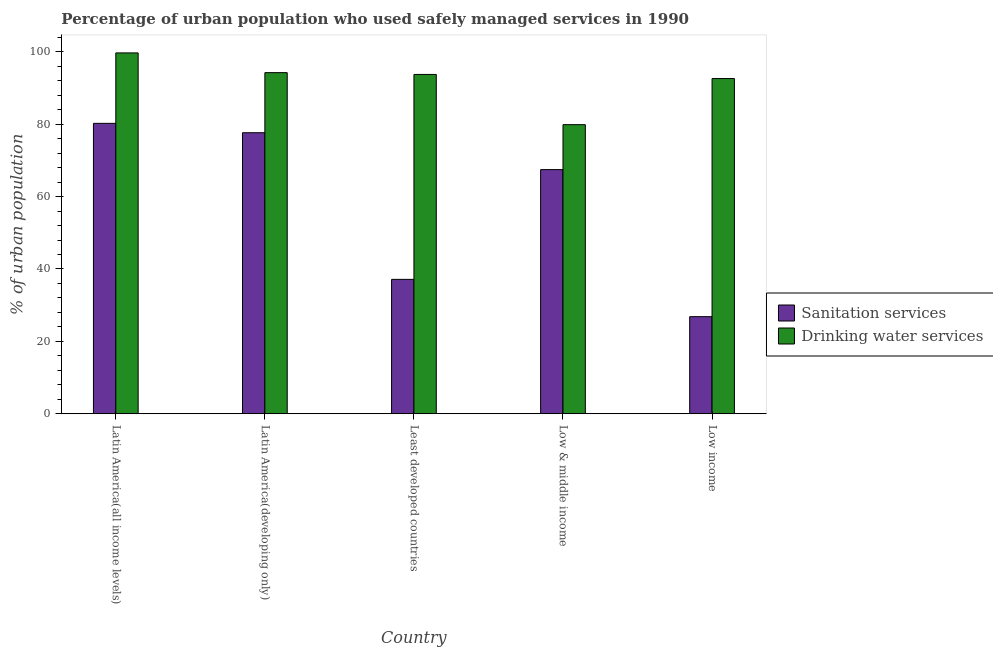How many groups of bars are there?
Give a very brief answer. 5. Are the number of bars per tick equal to the number of legend labels?
Give a very brief answer. Yes. How many bars are there on the 1st tick from the left?
Ensure brevity in your answer.  2. How many bars are there on the 3rd tick from the right?
Give a very brief answer. 2. What is the percentage of urban population who used sanitation services in Low income?
Provide a succinct answer. 26.82. Across all countries, what is the maximum percentage of urban population who used drinking water services?
Give a very brief answer. 99.69. Across all countries, what is the minimum percentage of urban population who used sanitation services?
Provide a succinct answer. 26.82. In which country was the percentage of urban population who used sanitation services maximum?
Give a very brief answer. Latin America(all income levels). In which country was the percentage of urban population who used sanitation services minimum?
Ensure brevity in your answer.  Low income. What is the total percentage of urban population who used drinking water services in the graph?
Make the answer very short. 460.16. What is the difference between the percentage of urban population who used drinking water services in Low & middle income and that in Low income?
Keep it short and to the point. -12.74. What is the difference between the percentage of urban population who used sanitation services in Latin America(all income levels) and the percentage of urban population who used drinking water services in Low & middle income?
Give a very brief answer. 0.36. What is the average percentage of urban population who used sanitation services per country?
Provide a short and direct response. 57.85. What is the difference between the percentage of urban population who used sanitation services and percentage of urban population who used drinking water services in Latin America(all income levels)?
Provide a succinct answer. -19.46. In how many countries, is the percentage of urban population who used drinking water services greater than 92 %?
Keep it short and to the point. 4. What is the ratio of the percentage of urban population who used drinking water services in Latin America(developing only) to that in Least developed countries?
Provide a succinct answer. 1.01. Is the percentage of urban population who used sanitation services in Latin America(all income levels) less than that in Least developed countries?
Offer a terse response. No. What is the difference between the highest and the second highest percentage of urban population who used sanitation services?
Provide a short and direct response. 2.59. What is the difference between the highest and the lowest percentage of urban population who used drinking water services?
Provide a succinct answer. 19.82. What does the 1st bar from the left in Low income represents?
Make the answer very short. Sanitation services. What does the 2nd bar from the right in Latin America(all income levels) represents?
Ensure brevity in your answer.  Sanitation services. Are all the bars in the graph horizontal?
Ensure brevity in your answer.  No. What is the difference between two consecutive major ticks on the Y-axis?
Your response must be concise. 20. Does the graph contain any zero values?
Provide a succinct answer. No. Where does the legend appear in the graph?
Your answer should be compact. Center right. How many legend labels are there?
Keep it short and to the point. 2. What is the title of the graph?
Offer a terse response. Percentage of urban population who used safely managed services in 1990. Does "From production" appear as one of the legend labels in the graph?
Ensure brevity in your answer.  No. What is the label or title of the X-axis?
Provide a short and direct response. Country. What is the label or title of the Y-axis?
Make the answer very short. % of urban population. What is the % of urban population in Sanitation services in Latin America(all income levels)?
Your answer should be very brief. 80.23. What is the % of urban population in Drinking water services in Latin America(all income levels)?
Offer a very short reply. 99.69. What is the % of urban population of Sanitation services in Latin America(developing only)?
Your response must be concise. 77.64. What is the % of urban population of Drinking water services in Latin America(developing only)?
Provide a short and direct response. 94.24. What is the % of urban population of Sanitation services in Least developed countries?
Offer a very short reply. 37.12. What is the % of urban population of Drinking water services in Least developed countries?
Offer a very short reply. 93.75. What is the % of urban population of Sanitation services in Low & middle income?
Offer a terse response. 67.45. What is the % of urban population of Drinking water services in Low & middle income?
Offer a very short reply. 79.87. What is the % of urban population of Sanitation services in Low income?
Your answer should be compact. 26.82. What is the % of urban population of Drinking water services in Low income?
Give a very brief answer. 92.61. Across all countries, what is the maximum % of urban population in Sanitation services?
Keep it short and to the point. 80.23. Across all countries, what is the maximum % of urban population in Drinking water services?
Provide a short and direct response. 99.69. Across all countries, what is the minimum % of urban population in Sanitation services?
Provide a short and direct response. 26.82. Across all countries, what is the minimum % of urban population in Drinking water services?
Keep it short and to the point. 79.87. What is the total % of urban population of Sanitation services in the graph?
Offer a very short reply. 289.27. What is the total % of urban population in Drinking water services in the graph?
Offer a very short reply. 460.16. What is the difference between the % of urban population in Sanitation services in Latin America(all income levels) and that in Latin America(developing only)?
Your response must be concise. 2.59. What is the difference between the % of urban population of Drinking water services in Latin America(all income levels) and that in Latin America(developing only)?
Provide a short and direct response. 5.45. What is the difference between the % of urban population of Sanitation services in Latin America(all income levels) and that in Least developed countries?
Provide a short and direct response. 43.11. What is the difference between the % of urban population of Drinking water services in Latin America(all income levels) and that in Least developed countries?
Provide a succinct answer. 5.95. What is the difference between the % of urban population in Sanitation services in Latin America(all income levels) and that in Low & middle income?
Provide a short and direct response. 12.78. What is the difference between the % of urban population of Drinking water services in Latin America(all income levels) and that in Low & middle income?
Provide a short and direct response. 19.82. What is the difference between the % of urban population in Sanitation services in Latin America(all income levels) and that in Low income?
Ensure brevity in your answer.  53.41. What is the difference between the % of urban population in Drinking water services in Latin America(all income levels) and that in Low income?
Make the answer very short. 7.09. What is the difference between the % of urban population of Sanitation services in Latin America(developing only) and that in Least developed countries?
Provide a short and direct response. 40.52. What is the difference between the % of urban population of Drinking water services in Latin America(developing only) and that in Least developed countries?
Provide a short and direct response. 0.49. What is the difference between the % of urban population in Sanitation services in Latin America(developing only) and that in Low & middle income?
Keep it short and to the point. 10.19. What is the difference between the % of urban population in Drinking water services in Latin America(developing only) and that in Low & middle income?
Provide a short and direct response. 14.37. What is the difference between the % of urban population in Sanitation services in Latin America(developing only) and that in Low income?
Make the answer very short. 50.82. What is the difference between the % of urban population of Drinking water services in Latin America(developing only) and that in Low income?
Provide a succinct answer. 1.63. What is the difference between the % of urban population in Sanitation services in Least developed countries and that in Low & middle income?
Make the answer very short. -30.33. What is the difference between the % of urban population in Drinking water services in Least developed countries and that in Low & middle income?
Your answer should be compact. 13.88. What is the difference between the % of urban population of Sanitation services in Least developed countries and that in Low income?
Provide a short and direct response. 10.3. What is the difference between the % of urban population in Drinking water services in Least developed countries and that in Low income?
Make the answer very short. 1.14. What is the difference between the % of urban population of Sanitation services in Low & middle income and that in Low income?
Your answer should be very brief. 40.63. What is the difference between the % of urban population of Drinking water services in Low & middle income and that in Low income?
Provide a succinct answer. -12.74. What is the difference between the % of urban population in Sanitation services in Latin America(all income levels) and the % of urban population in Drinking water services in Latin America(developing only)?
Your answer should be very brief. -14.01. What is the difference between the % of urban population in Sanitation services in Latin America(all income levels) and the % of urban population in Drinking water services in Least developed countries?
Offer a terse response. -13.52. What is the difference between the % of urban population in Sanitation services in Latin America(all income levels) and the % of urban population in Drinking water services in Low & middle income?
Your response must be concise. 0.36. What is the difference between the % of urban population in Sanitation services in Latin America(all income levels) and the % of urban population in Drinking water services in Low income?
Offer a terse response. -12.38. What is the difference between the % of urban population in Sanitation services in Latin America(developing only) and the % of urban population in Drinking water services in Least developed countries?
Ensure brevity in your answer.  -16.11. What is the difference between the % of urban population of Sanitation services in Latin America(developing only) and the % of urban population of Drinking water services in Low & middle income?
Make the answer very short. -2.23. What is the difference between the % of urban population of Sanitation services in Latin America(developing only) and the % of urban population of Drinking water services in Low income?
Provide a succinct answer. -14.97. What is the difference between the % of urban population of Sanitation services in Least developed countries and the % of urban population of Drinking water services in Low & middle income?
Offer a terse response. -42.74. What is the difference between the % of urban population of Sanitation services in Least developed countries and the % of urban population of Drinking water services in Low income?
Offer a very short reply. -55.48. What is the difference between the % of urban population in Sanitation services in Low & middle income and the % of urban population in Drinking water services in Low income?
Make the answer very short. -25.16. What is the average % of urban population in Sanitation services per country?
Provide a short and direct response. 57.85. What is the average % of urban population of Drinking water services per country?
Ensure brevity in your answer.  92.03. What is the difference between the % of urban population of Sanitation services and % of urban population of Drinking water services in Latin America(all income levels)?
Provide a succinct answer. -19.46. What is the difference between the % of urban population of Sanitation services and % of urban population of Drinking water services in Latin America(developing only)?
Your answer should be compact. -16.6. What is the difference between the % of urban population in Sanitation services and % of urban population in Drinking water services in Least developed countries?
Offer a very short reply. -56.62. What is the difference between the % of urban population of Sanitation services and % of urban population of Drinking water services in Low & middle income?
Your answer should be very brief. -12.42. What is the difference between the % of urban population of Sanitation services and % of urban population of Drinking water services in Low income?
Give a very brief answer. -65.79. What is the ratio of the % of urban population of Sanitation services in Latin America(all income levels) to that in Latin America(developing only)?
Your response must be concise. 1.03. What is the ratio of the % of urban population of Drinking water services in Latin America(all income levels) to that in Latin America(developing only)?
Offer a terse response. 1.06. What is the ratio of the % of urban population in Sanitation services in Latin America(all income levels) to that in Least developed countries?
Offer a terse response. 2.16. What is the ratio of the % of urban population of Drinking water services in Latin America(all income levels) to that in Least developed countries?
Keep it short and to the point. 1.06. What is the ratio of the % of urban population in Sanitation services in Latin America(all income levels) to that in Low & middle income?
Offer a terse response. 1.19. What is the ratio of the % of urban population of Drinking water services in Latin America(all income levels) to that in Low & middle income?
Keep it short and to the point. 1.25. What is the ratio of the % of urban population of Sanitation services in Latin America(all income levels) to that in Low income?
Your response must be concise. 2.99. What is the ratio of the % of urban population in Drinking water services in Latin America(all income levels) to that in Low income?
Provide a succinct answer. 1.08. What is the ratio of the % of urban population of Sanitation services in Latin America(developing only) to that in Least developed countries?
Offer a very short reply. 2.09. What is the ratio of the % of urban population in Sanitation services in Latin America(developing only) to that in Low & middle income?
Your response must be concise. 1.15. What is the ratio of the % of urban population of Drinking water services in Latin America(developing only) to that in Low & middle income?
Offer a terse response. 1.18. What is the ratio of the % of urban population in Sanitation services in Latin America(developing only) to that in Low income?
Provide a short and direct response. 2.89. What is the ratio of the % of urban population in Drinking water services in Latin America(developing only) to that in Low income?
Your answer should be very brief. 1.02. What is the ratio of the % of urban population in Sanitation services in Least developed countries to that in Low & middle income?
Offer a very short reply. 0.55. What is the ratio of the % of urban population of Drinking water services in Least developed countries to that in Low & middle income?
Give a very brief answer. 1.17. What is the ratio of the % of urban population of Sanitation services in Least developed countries to that in Low income?
Offer a terse response. 1.38. What is the ratio of the % of urban population in Drinking water services in Least developed countries to that in Low income?
Your answer should be compact. 1.01. What is the ratio of the % of urban population of Sanitation services in Low & middle income to that in Low income?
Keep it short and to the point. 2.51. What is the ratio of the % of urban population of Drinking water services in Low & middle income to that in Low income?
Give a very brief answer. 0.86. What is the difference between the highest and the second highest % of urban population of Sanitation services?
Ensure brevity in your answer.  2.59. What is the difference between the highest and the second highest % of urban population of Drinking water services?
Keep it short and to the point. 5.45. What is the difference between the highest and the lowest % of urban population in Sanitation services?
Offer a terse response. 53.41. What is the difference between the highest and the lowest % of urban population in Drinking water services?
Your answer should be very brief. 19.82. 